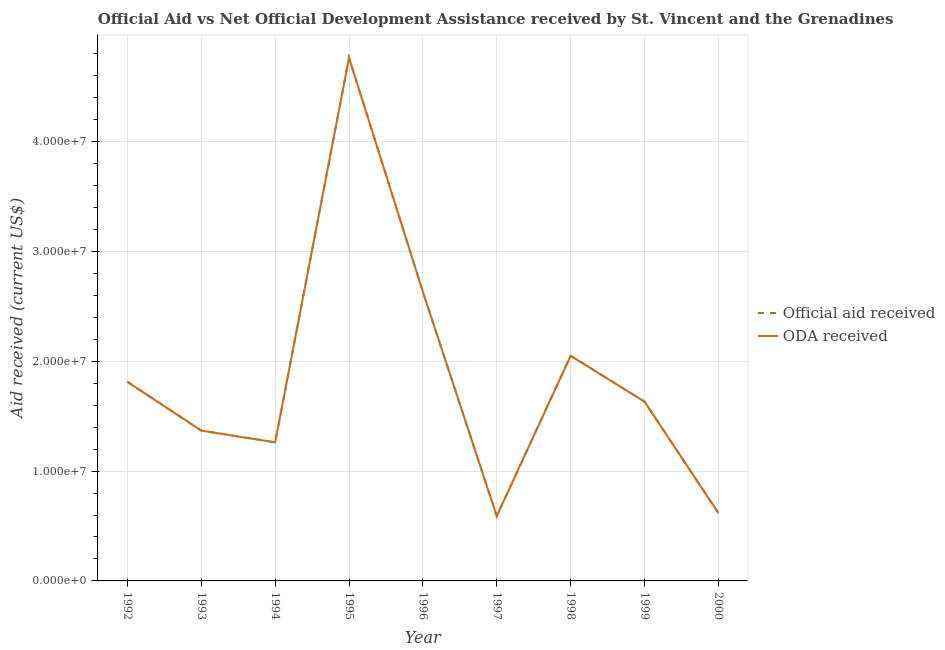Does the line corresponding to official aid received intersect with the line corresponding to oda received?
Your answer should be compact. Yes. What is the official aid received in 1998?
Your answer should be very brief. 2.05e+07. Across all years, what is the maximum official aid received?
Provide a succinct answer. 4.76e+07. Across all years, what is the minimum oda received?
Ensure brevity in your answer.  5.90e+06. In which year was the official aid received maximum?
Your response must be concise. 1995. What is the total official aid received in the graph?
Your response must be concise. 1.67e+08. What is the difference between the oda received in 1996 and that in 2000?
Keep it short and to the point. 2.01e+07. What is the difference between the oda received in 1993 and the official aid received in 1998?
Provide a short and direct response. -6.81e+06. What is the average official aid received per year?
Provide a short and direct response. 1.86e+07. What is the ratio of the official aid received in 1992 to that in 1994?
Your answer should be compact. 1.44. Is the difference between the official aid received in 1994 and 2000 greater than the difference between the oda received in 1994 and 2000?
Provide a succinct answer. No. What is the difference between the highest and the second highest oda received?
Give a very brief answer. 2.13e+07. What is the difference between the highest and the lowest official aid received?
Your answer should be very brief. 4.17e+07. In how many years, is the oda received greater than the average oda received taken over all years?
Your answer should be very brief. 3. Does the official aid received monotonically increase over the years?
Offer a terse response. No. Is the official aid received strictly greater than the oda received over the years?
Make the answer very short. No. Is the official aid received strictly less than the oda received over the years?
Make the answer very short. No. How many lines are there?
Your answer should be compact. 2. What is the difference between two consecutive major ticks on the Y-axis?
Give a very brief answer. 1.00e+07. Does the graph contain grids?
Offer a terse response. Yes. How are the legend labels stacked?
Ensure brevity in your answer.  Vertical. What is the title of the graph?
Offer a terse response. Official Aid vs Net Official Development Assistance received by St. Vincent and the Grenadines . What is the label or title of the Y-axis?
Offer a very short reply. Aid received (current US$). What is the Aid received (current US$) of Official aid received in 1992?
Provide a short and direct response. 1.81e+07. What is the Aid received (current US$) of ODA received in 1992?
Ensure brevity in your answer.  1.81e+07. What is the Aid received (current US$) in Official aid received in 1993?
Provide a short and direct response. 1.37e+07. What is the Aid received (current US$) of ODA received in 1993?
Make the answer very short. 1.37e+07. What is the Aid received (current US$) in Official aid received in 1994?
Ensure brevity in your answer.  1.26e+07. What is the Aid received (current US$) in ODA received in 1994?
Your response must be concise. 1.26e+07. What is the Aid received (current US$) in Official aid received in 1995?
Offer a terse response. 4.76e+07. What is the Aid received (current US$) in ODA received in 1995?
Offer a very short reply. 4.76e+07. What is the Aid received (current US$) of Official aid received in 1996?
Your answer should be compact. 2.63e+07. What is the Aid received (current US$) of ODA received in 1996?
Ensure brevity in your answer.  2.63e+07. What is the Aid received (current US$) of Official aid received in 1997?
Offer a terse response. 5.90e+06. What is the Aid received (current US$) in ODA received in 1997?
Your answer should be very brief. 5.90e+06. What is the Aid received (current US$) of Official aid received in 1998?
Make the answer very short. 2.05e+07. What is the Aid received (current US$) in ODA received in 1998?
Give a very brief answer. 2.05e+07. What is the Aid received (current US$) of Official aid received in 1999?
Keep it short and to the point. 1.63e+07. What is the Aid received (current US$) in ODA received in 1999?
Offer a very short reply. 1.63e+07. What is the Aid received (current US$) in Official aid received in 2000?
Provide a succinct answer. 6.18e+06. What is the Aid received (current US$) in ODA received in 2000?
Make the answer very short. 6.18e+06. Across all years, what is the maximum Aid received (current US$) of Official aid received?
Provide a succinct answer. 4.76e+07. Across all years, what is the maximum Aid received (current US$) of ODA received?
Your response must be concise. 4.76e+07. Across all years, what is the minimum Aid received (current US$) of Official aid received?
Your answer should be very brief. 5.90e+06. Across all years, what is the minimum Aid received (current US$) of ODA received?
Ensure brevity in your answer.  5.90e+06. What is the total Aid received (current US$) in Official aid received in the graph?
Your answer should be very brief. 1.67e+08. What is the total Aid received (current US$) in ODA received in the graph?
Make the answer very short. 1.67e+08. What is the difference between the Aid received (current US$) in Official aid received in 1992 and that in 1993?
Provide a short and direct response. 4.44e+06. What is the difference between the Aid received (current US$) of ODA received in 1992 and that in 1993?
Offer a terse response. 4.44e+06. What is the difference between the Aid received (current US$) in Official aid received in 1992 and that in 1994?
Provide a succinct answer. 5.51e+06. What is the difference between the Aid received (current US$) in ODA received in 1992 and that in 1994?
Your answer should be very brief. 5.51e+06. What is the difference between the Aid received (current US$) of Official aid received in 1992 and that in 1995?
Ensure brevity in your answer.  -2.95e+07. What is the difference between the Aid received (current US$) in ODA received in 1992 and that in 1995?
Your answer should be compact. -2.95e+07. What is the difference between the Aid received (current US$) in Official aid received in 1992 and that in 1996?
Keep it short and to the point. -8.19e+06. What is the difference between the Aid received (current US$) in ODA received in 1992 and that in 1996?
Your answer should be compact. -8.19e+06. What is the difference between the Aid received (current US$) in Official aid received in 1992 and that in 1997?
Offer a terse response. 1.22e+07. What is the difference between the Aid received (current US$) in ODA received in 1992 and that in 1997?
Your answer should be compact. 1.22e+07. What is the difference between the Aid received (current US$) of Official aid received in 1992 and that in 1998?
Your response must be concise. -2.37e+06. What is the difference between the Aid received (current US$) of ODA received in 1992 and that in 1998?
Your response must be concise. -2.37e+06. What is the difference between the Aid received (current US$) of Official aid received in 1992 and that in 1999?
Give a very brief answer. 1.80e+06. What is the difference between the Aid received (current US$) of ODA received in 1992 and that in 1999?
Provide a short and direct response. 1.80e+06. What is the difference between the Aid received (current US$) in Official aid received in 1992 and that in 2000?
Keep it short and to the point. 1.20e+07. What is the difference between the Aid received (current US$) of ODA received in 1992 and that in 2000?
Offer a terse response. 1.20e+07. What is the difference between the Aid received (current US$) in Official aid received in 1993 and that in 1994?
Provide a succinct answer. 1.07e+06. What is the difference between the Aid received (current US$) of ODA received in 1993 and that in 1994?
Give a very brief answer. 1.07e+06. What is the difference between the Aid received (current US$) of Official aid received in 1993 and that in 1995?
Your answer should be very brief. -3.40e+07. What is the difference between the Aid received (current US$) of ODA received in 1993 and that in 1995?
Ensure brevity in your answer.  -3.40e+07. What is the difference between the Aid received (current US$) in Official aid received in 1993 and that in 1996?
Your answer should be compact. -1.26e+07. What is the difference between the Aid received (current US$) of ODA received in 1993 and that in 1996?
Offer a very short reply. -1.26e+07. What is the difference between the Aid received (current US$) of Official aid received in 1993 and that in 1997?
Your answer should be compact. 7.79e+06. What is the difference between the Aid received (current US$) in ODA received in 1993 and that in 1997?
Ensure brevity in your answer.  7.79e+06. What is the difference between the Aid received (current US$) of Official aid received in 1993 and that in 1998?
Your answer should be compact. -6.81e+06. What is the difference between the Aid received (current US$) in ODA received in 1993 and that in 1998?
Offer a terse response. -6.81e+06. What is the difference between the Aid received (current US$) of Official aid received in 1993 and that in 1999?
Offer a very short reply. -2.64e+06. What is the difference between the Aid received (current US$) of ODA received in 1993 and that in 1999?
Offer a very short reply. -2.64e+06. What is the difference between the Aid received (current US$) of Official aid received in 1993 and that in 2000?
Your answer should be very brief. 7.51e+06. What is the difference between the Aid received (current US$) of ODA received in 1993 and that in 2000?
Offer a terse response. 7.51e+06. What is the difference between the Aid received (current US$) in Official aid received in 1994 and that in 1995?
Give a very brief answer. -3.50e+07. What is the difference between the Aid received (current US$) in ODA received in 1994 and that in 1995?
Offer a terse response. -3.50e+07. What is the difference between the Aid received (current US$) in Official aid received in 1994 and that in 1996?
Your answer should be compact. -1.37e+07. What is the difference between the Aid received (current US$) in ODA received in 1994 and that in 1996?
Provide a succinct answer. -1.37e+07. What is the difference between the Aid received (current US$) of Official aid received in 1994 and that in 1997?
Give a very brief answer. 6.72e+06. What is the difference between the Aid received (current US$) in ODA received in 1994 and that in 1997?
Your response must be concise. 6.72e+06. What is the difference between the Aid received (current US$) in Official aid received in 1994 and that in 1998?
Your response must be concise. -7.88e+06. What is the difference between the Aid received (current US$) of ODA received in 1994 and that in 1998?
Your answer should be compact. -7.88e+06. What is the difference between the Aid received (current US$) in Official aid received in 1994 and that in 1999?
Provide a short and direct response. -3.71e+06. What is the difference between the Aid received (current US$) in ODA received in 1994 and that in 1999?
Provide a succinct answer. -3.71e+06. What is the difference between the Aid received (current US$) in Official aid received in 1994 and that in 2000?
Keep it short and to the point. 6.44e+06. What is the difference between the Aid received (current US$) of ODA received in 1994 and that in 2000?
Give a very brief answer. 6.44e+06. What is the difference between the Aid received (current US$) of Official aid received in 1995 and that in 1996?
Keep it short and to the point. 2.13e+07. What is the difference between the Aid received (current US$) of ODA received in 1995 and that in 1996?
Your response must be concise. 2.13e+07. What is the difference between the Aid received (current US$) in Official aid received in 1995 and that in 1997?
Make the answer very short. 4.17e+07. What is the difference between the Aid received (current US$) in ODA received in 1995 and that in 1997?
Keep it short and to the point. 4.17e+07. What is the difference between the Aid received (current US$) of Official aid received in 1995 and that in 1998?
Your answer should be very brief. 2.71e+07. What is the difference between the Aid received (current US$) of ODA received in 1995 and that in 1998?
Ensure brevity in your answer.  2.71e+07. What is the difference between the Aid received (current US$) of Official aid received in 1995 and that in 1999?
Ensure brevity in your answer.  3.13e+07. What is the difference between the Aid received (current US$) of ODA received in 1995 and that in 1999?
Your answer should be compact. 3.13e+07. What is the difference between the Aid received (current US$) of Official aid received in 1995 and that in 2000?
Your response must be concise. 4.15e+07. What is the difference between the Aid received (current US$) in ODA received in 1995 and that in 2000?
Offer a very short reply. 4.15e+07. What is the difference between the Aid received (current US$) of Official aid received in 1996 and that in 1997?
Offer a terse response. 2.04e+07. What is the difference between the Aid received (current US$) in ODA received in 1996 and that in 1997?
Offer a very short reply. 2.04e+07. What is the difference between the Aid received (current US$) in Official aid received in 1996 and that in 1998?
Provide a succinct answer. 5.82e+06. What is the difference between the Aid received (current US$) in ODA received in 1996 and that in 1998?
Offer a terse response. 5.82e+06. What is the difference between the Aid received (current US$) of Official aid received in 1996 and that in 1999?
Give a very brief answer. 9.99e+06. What is the difference between the Aid received (current US$) in ODA received in 1996 and that in 1999?
Make the answer very short. 9.99e+06. What is the difference between the Aid received (current US$) of Official aid received in 1996 and that in 2000?
Keep it short and to the point. 2.01e+07. What is the difference between the Aid received (current US$) in ODA received in 1996 and that in 2000?
Provide a succinct answer. 2.01e+07. What is the difference between the Aid received (current US$) of Official aid received in 1997 and that in 1998?
Keep it short and to the point. -1.46e+07. What is the difference between the Aid received (current US$) of ODA received in 1997 and that in 1998?
Your answer should be very brief. -1.46e+07. What is the difference between the Aid received (current US$) in Official aid received in 1997 and that in 1999?
Offer a terse response. -1.04e+07. What is the difference between the Aid received (current US$) in ODA received in 1997 and that in 1999?
Provide a short and direct response. -1.04e+07. What is the difference between the Aid received (current US$) of Official aid received in 1997 and that in 2000?
Offer a terse response. -2.80e+05. What is the difference between the Aid received (current US$) of ODA received in 1997 and that in 2000?
Your response must be concise. -2.80e+05. What is the difference between the Aid received (current US$) of Official aid received in 1998 and that in 1999?
Offer a very short reply. 4.17e+06. What is the difference between the Aid received (current US$) in ODA received in 1998 and that in 1999?
Give a very brief answer. 4.17e+06. What is the difference between the Aid received (current US$) of Official aid received in 1998 and that in 2000?
Provide a succinct answer. 1.43e+07. What is the difference between the Aid received (current US$) in ODA received in 1998 and that in 2000?
Your answer should be compact. 1.43e+07. What is the difference between the Aid received (current US$) of Official aid received in 1999 and that in 2000?
Ensure brevity in your answer.  1.02e+07. What is the difference between the Aid received (current US$) of ODA received in 1999 and that in 2000?
Keep it short and to the point. 1.02e+07. What is the difference between the Aid received (current US$) in Official aid received in 1992 and the Aid received (current US$) in ODA received in 1993?
Ensure brevity in your answer.  4.44e+06. What is the difference between the Aid received (current US$) in Official aid received in 1992 and the Aid received (current US$) in ODA received in 1994?
Give a very brief answer. 5.51e+06. What is the difference between the Aid received (current US$) of Official aid received in 1992 and the Aid received (current US$) of ODA received in 1995?
Your answer should be very brief. -2.95e+07. What is the difference between the Aid received (current US$) of Official aid received in 1992 and the Aid received (current US$) of ODA received in 1996?
Offer a very short reply. -8.19e+06. What is the difference between the Aid received (current US$) of Official aid received in 1992 and the Aid received (current US$) of ODA received in 1997?
Give a very brief answer. 1.22e+07. What is the difference between the Aid received (current US$) in Official aid received in 1992 and the Aid received (current US$) in ODA received in 1998?
Your response must be concise. -2.37e+06. What is the difference between the Aid received (current US$) in Official aid received in 1992 and the Aid received (current US$) in ODA received in 1999?
Keep it short and to the point. 1.80e+06. What is the difference between the Aid received (current US$) in Official aid received in 1992 and the Aid received (current US$) in ODA received in 2000?
Give a very brief answer. 1.20e+07. What is the difference between the Aid received (current US$) of Official aid received in 1993 and the Aid received (current US$) of ODA received in 1994?
Provide a succinct answer. 1.07e+06. What is the difference between the Aid received (current US$) of Official aid received in 1993 and the Aid received (current US$) of ODA received in 1995?
Make the answer very short. -3.40e+07. What is the difference between the Aid received (current US$) of Official aid received in 1993 and the Aid received (current US$) of ODA received in 1996?
Provide a succinct answer. -1.26e+07. What is the difference between the Aid received (current US$) of Official aid received in 1993 and the Aid received (current US$) of ODA received in 1997?
Offer a terse response. 7.79e+06. What is the difference between the Aid received (current US$) in Official aid received in 1993 and the Aid received (current US$) in ODA received in 1998?
Give a very brief answer. -6.81e+06. What is the difference between the Aid received (current US$) of Official aid received in 1993 and the Aid received (current US$) of ODA received in 1999?
Offer a very short reply. -2.64e+06. What is the difference between the Aid received (current US$) in Official aid received in 1993 and the Aid received (current US$) in ODA received in 2000?
Make the answer very short. 7.51e+06. What is the difference between the Aid received (current US$) of Official aid received in 1994 and the Aid received (current US$) of ODA received in 1995?
Give a very brief answer. -3.50e+07. What is the difference between the Aid received (current US$) in Official aid received in 1994 and the Aid received (current US$) in ODA received in 1996?
Your response must be concise. -1.37e+07. What is the difference between the Aid received (current US$) in Official aid received in 1994 and the Aid received (current US$) in ODA received in 1997?
Offer a very short reply. 6.72e+06. What is the difference between the Aid received (current US$) of Official aid received in 1994 and the Aid received (current US$) of ODA received in 1998?
Make the answer very short. -7.88e+06. What is the difference between the Aid received (current US$) of Official aid received in 1994 and the Aid received (current US$) of ODA received in 1999?
Your answer should be compact. -3.71e+06. What is the difference between the Aid received (current US$) of Official aid received in 1994 and the Aid received (current US$) of ODA received in 2000?
Offer a very short reply. 6.44e+06. What is the difference between the Aid received (current US$) in Official aid received in 1995 and the Aid received (current US$) in ODA received in 1996?
Offer a terse response. 2.13e+07. What is the difference between the Aid received (current US$) in Official aid received in 1995 and the Aid received (current US$) in ODA received in 1997?
Provide a short and direct response. 4.17e+07. What is the difference between the Aid received (current US$) in Official aid received in 1995 and the Aid received (current US$) in ODA received in 1998?
Your answer should be compact. 2.71e+07. What is the difference between the Aid received (current US$) in Official aid received in 1995 and the Aid received (current US$) in ODA received in 1999?
Ensure brevity in your answer.  3.13e+07. What is the difference between the Aid received (current US$) of Official aid received in 1995 and the Aid received (current US$) of ODA received in 2000?
Offer a terse response. 4.15e+07. What is the difference between the Aid received (current US$) in Official aid received in 1996 and the Aid received (current US$) in ODA received in 1997?
Provide a succinct answer. 2.04e+07. What is the difference between the Aid received (current US$) of Official aid received in 1996 and the Aid received (current US$) of ODA received in 1998?
Keep it short and to the point. 5.82e+06. What is the difference between the Aid received (current US$) of Official aid received in 1996 and the Aid received (current US$) of ODA received in 1999?
Make the answer very short. 9.99e+06. What is the difference between the Aid received (current US$) in Official aid received in 1996 and the Aid received (current US$) in ODA received in 2000?
Offer a terse response. 2.01e+07. What is the difference between the Aid received (current US$) of Official aid received in 1997 and the Aid received (current US$) of ODA received in 1998?
Your response must be concise. -1.46e+07. What is the difference between the Aid received (current US$) in Official aid received in 1997 and the Aid received (current US$) in ODA received in 1999?
Provide a succinct answer. -1.04e+07. What is the difference between the Aid received (current US$) in Official aid received in 1997 and the Aid received (current US$) in ODA received in 2000?
Ensure brevity in your answer.  -2.80e+05. What is the difference between the Aid received (current US$) in Official aid received in 1998 and the Aid received (current US$) in ODA received in 1999?
Provide a short and direct response. 4.17e+06. What is the difference between the Aid received (current US$) in Official aid received in 1998 and the Aid received (current US$) in ODA received in 2000?
Provide a succinct answer. 1.43e+07. What is the difference between the Aid received (current US$) of Official aid received in 1999 and the Aid received (current US$) of ODA received in 2000?
Provide a succinct answer. 1.02e+07. What is the average Aid received (current US$) in Official aid received per year?
Provide a succinct answer. 1.86e+07. What is the average Aid received (current US$) in ODA received per year?
Your answer should be compact. 1.86e+07. In the year 1992, what is the difference between the Aid received (current US$) of Official aid received and Aid received (current US$) of ODA received?
Give a very brief answer. 0. In the year 1994, what is the difference between the Aid received (current US$) in Official aid received and Aid received (current US$) in ODA received?
Offer a terse response. 0. In the year 1996, what is the difference between the Aid received (current US$) of Official aid received and Aid received (current US$) of ODA received?
Provide a short and direct response. 0. In the year 1998, what is the difference between the Aid received (current US$) of Official aid received and Aid received (current US$) of ODA received?
Give a very brief answer. 0. In the year 2000, what is the difference between the Aid received (current US$) in Official aid received and Aid received (current US$) in ODA received?
Make the answer very short. 0. What is the ratio of the Aid received (current US$) of Official aid received in 1992 to that in 1993?
Your answer should be compact. 1.32. What is the ratio of the Aid received (current US$) in ODA received in 1992 to that in 1993?
Provide a succinct answer. 1.32. What is the ratio of the Aid received (current US$) of Official aid received in 1992 to that in 1994?
Your answer should be very brief. 1.44. What is the ratio of the Aid received (current US$) of ODA received in 1992 to that in 1994?
Give a very brief answer. 1.44. What is the ratio of the Aid received (current US$) in Official aid received in 1992 to that in 1995?
Your answer should be very brief. 0.38. What is the ratio of the Aid received (current US$) of ODA received in 1992 to that in 1995?
Give a very brief answer. 0.38. What is the ratio of the Aid received (current US$) in Official aid received in 1992 to that in 1996?
Provide a succinct answer. 0.69. What is the ratio of the Aid received (current US$) in ODA received in 1992 to that in 1996?
Give a very brief answer. 0.69. What is the ratio of the Aid received (current US$) of Official aid received in 1992 to that in 1997?
Keep it short and to the point. 3.07. What is the ratio of the Aid received (current US$) of ODA received in 1992 to that in 1997?
Your answer should be compact. 3.07. What is the ratio of the Aid received (current US$) of Official aid received in 1992 to that in 1998?
Your response must be concise. 0.88. What is the ratio of the Aid received (current US$) in ODA received in 1992 to that in 1998?
Offer a very short reply. 0.88. What is the ratio of the Aid received (current US$) in Official aid received in 1992 to that in 1999?
Your answer should be very brief. 1.11. What is the ratio of the Aid received (current US$) in ODA received in 1992 to that in 1999?
Offer a terse response. 1.11. What is the ratio of the Aid received (current US$) in Official aid received in 1992 to that in 2000?
Provide a short and direct response. 2.93. What is the ratio of the Aid received (current US$) in ODA received in 1992 to that in 2000?
Ensure brevity in your answer.  2.93. What is the ratio of the Aid received (current US$) of Official aid received in 1993 to that in 1994?
Your response must be concise. 1.08. What is the ratio of the Aid received (current US$) in ODA received in 1993 to that in 1994?
Give a very brief answer. 1.08. What is the ratio of the Aid received (current US$) of Official aid received in 1993 to that in 1995?
Keep it short and to the point. 0.29. What is the ratio of the Aid received (current US$) in ODA received in 1993 to that in 1995?
Your answer should be compact. 0.29. What is the ratio of the Aid received (current US$) of Official aid received in 1993 to that in 1996?
Offer a very short reply. 0.52. What is the ratio of the Aid received (current US$) of ODA received in 1993 to that in 1996?
Your answer should be compact. 0.52. What is the ratio of the Aid received (current US$) in Official aid received in 1993 to that in 1997?
Offer a very short reply. 2.32. What is the ratio of the Aid received (current US$) of ODA received in 1993 to that in 1997?
Your answer should be compact. 2.32. What is the ratio of the Aid received (current US$) in Official aid received in 1993 to that in 1998?
Your answer should be very brief. 0.67. What is the ratio of the Aid received (current US$) of ODA received in 1993 to that in 1998?
Provide a short and direct response. 0.67. What is the ratio of the Aid received (current US$) of Official aid received in 1993 to that in 1999?
Keep it short and to the point. 0.84. What is the ratio of the Aid received (current US$) in ODA received in 1993 to that in 1999?
Offer a very short reply. 0.84. What is the ratio of the Aid received (current US$) of Official aid received in 1993 to that in 2000?
Give a very brief answer. 2.22. What is the ratio of the Aid received (current US$) of ODA received in 1993 to that in 2000?
Make the answer very short. 2.22. What is the ratio of the Aid received (current US$) in Official aid received in 1994 to that in 1995?
Keep it short and to the point. 0.26. What is the ratio of the Aid received (current US$) in ODA received in 1994 to that in 1995?
Your answer should be very brief. 0.26. What is the ratio of the Aid received (current US$) in Official aid received in 1994 to that in 1996?
Provide a short and direct response. 0.48. What is the ratio of the Aid received (current US$) of ODA received in 1994 to that in 1996?
Offer a very short reply. 0.48. What is the ratio of the Aid received (current US$) in Official aid received in 1994 to that in 1997?
Keep it short and to the point. 2.14. What is the ratio of the Aid received (current US$) of ODA received in 1994 to that in 1997?
Provide a succinct answer. 2.14. What is the ratio of the Aid received (current US$) in Official aid received in 1994 to that in 1998?
Make the answer very short. 0.62. What is the ratio of the Aid received (current US$) of ODA received in 1994 to that in 1998?
Provide a succinct answer. 0.62. What is the ratio of the Aid received (current US$) in Official aid received in 1994 to that in 1999?
Keep it short and to the point. 0.77. What is the ratio of the Aid received (current US$) in ODA received in 1994 to that in 1999?
Make the answer very short. 0.77. What is the ratio of the Aid received (current US$) of Official aid received in 1994 to that in 2000?
Provide a succinct answer. 2.04. What is the ratio of the Aid received (current US$) of ODA received in 1994 to that in 2000?
Your answer should be compact. 2.04. What is the ratio of the Aid received (current US$) in Official aid received in 1995 to that in 1996?
Provide a short and direct response. 1.81. What is the ratio of the Aid received (current US$) of ODA received in 1995 to that in 1996?
Your answer should be very brief. 1.81. What is the ratio of the Aid received (current US$) of Official aid received in 1995 to that in 1997?
Give a very brief answer. 8.07. What is the ratio of the Aid received (current US$) of ODA received in 1995 to that in 1997?
Make the answer very short. 8.07. What is the ratio of the Aid received (current US$) in Official aid received in 1995 to that in 1998?
Keep it short and to the point. 2.32. What is the ratio of the Aid received (current US$) of ODA received in 1995 to that in 1998?
Offer a terse response. 2.32. What is the ratio of the Aid received (current US$) in Official aid received in 1995 to that in 1999?
Your answer should be very brief. 2.92. What is the ratio of the Aid received (current US$) of ODA received in 1995 to that in 1999?
Offer a very short reply. 2.92. What is the ratio of the Aid received (current US$) in Official aid received in 1995 to that in 2000?
Provide a short and direct response. 7.71. What is the ratio of the Aid received (current US$) of ODA received in 1995 to that in 2000?
Ensure brevity in your answer.  7.71. What is the ratio of the Aid received (current US$) in Official aid received in 1996 to that in 1997?
Ensure brevity in your answer.  4.46. What is the ratio of the Aid received (current US$) in ODA received in 1996 to that in 1997?
Offer a terse response. 4.46. What is the ratio of the Aid received (current US$) in Official aid received in 1996 to that in 1998?
Your response must be concise. 1.28. What is the ratio of the Aid received (current US$) in ODA received in 1996 to that in 1998?
Your answer should be compact. 1.28. What is the ratio of the Aid received (current US$) in Official aid received in 1996 to that in 1999?
Ensure brevity in your answer.  1.61. What is the ratio of the Aid received (current US$) in ODA received in 1996 to that in 1999?
Make the answer very short. 1.61. What is the ratio of the Aid received (current US$) in Official aid received in 1996 to that in 2000?
Provide a succinct answer. 4.26. What is the ratio of the Aid received (current US$) in ODA received in 1996 to that in 2000?
Make the answer very short. 4.26. What is the ratio of the Aid received (current US$) of Official aid received in 1997 to that in 1998?
Your answer should be compact. 0.29. What is the ratio of the Aid received (current US$) of ODA received in 1997 to that in 1998?
Ensure brevity in your answer.  0.29. What is the ratio of the Aid received (current US$) in Official aid received in 1997 to that in 1999?
Your answer should be compact. 0.36. What is the ratio of the Aid received (current US$) in ODA received in 1997 to that in 1999?
Offer a terse response. 0.36. What is the ratio of the Aid received (current US$) in Official aid received in 1997 to that in 2000?
Offer a terse response. 0.95. What is the ratio of the Aid received (current US$) in ODA received in 1997 to that in 2000?
Offer a terse response. 0.95. What is the ratio of the Aid received (current US$) of Official aid received in 1998 to that in 1999?
Give a very brief answer. 1.26. What is the ratio of the Aid received (current US$) of ODA received in 1998 to that in 1999?
Make the answer very short. 1.26. What is the ratio of the Aid received (current US$) in Official aid received in 1998 to that in 2000?
Give a very brief answer. 3.32. What is the ratio of the Aid received (current US$) in ODA received in 1998 to that in 2000?
Your answer should be compact. 3.32. What is the ratio of the Aid received (current US$) in Official aid received in 1999 to that in 2000?
Offer a terse response. 2.64. What is the ratio of the Aid received (current US$) in ODA received in 1999 to that in 2000?
Give a very brief answer. 2.64. What is the difference between the highest and the second highest Aid received (current US$) in Official aid received?
Your answer should be very brief. 2.13e+07. What is the difference between the highest and the second highest Aid received (current US$) of ODA received?
Your answer should be compact. 2.13e+07. What is the difference between the highest and the lowest Aid received (current US$) of Official aid received?
Keep it short and to the point. 4.17e+07. What is the difference between the highest and the lowest Aid received (current US$) of ODA received?
Your answer should be very brief. 4.17e+07. 